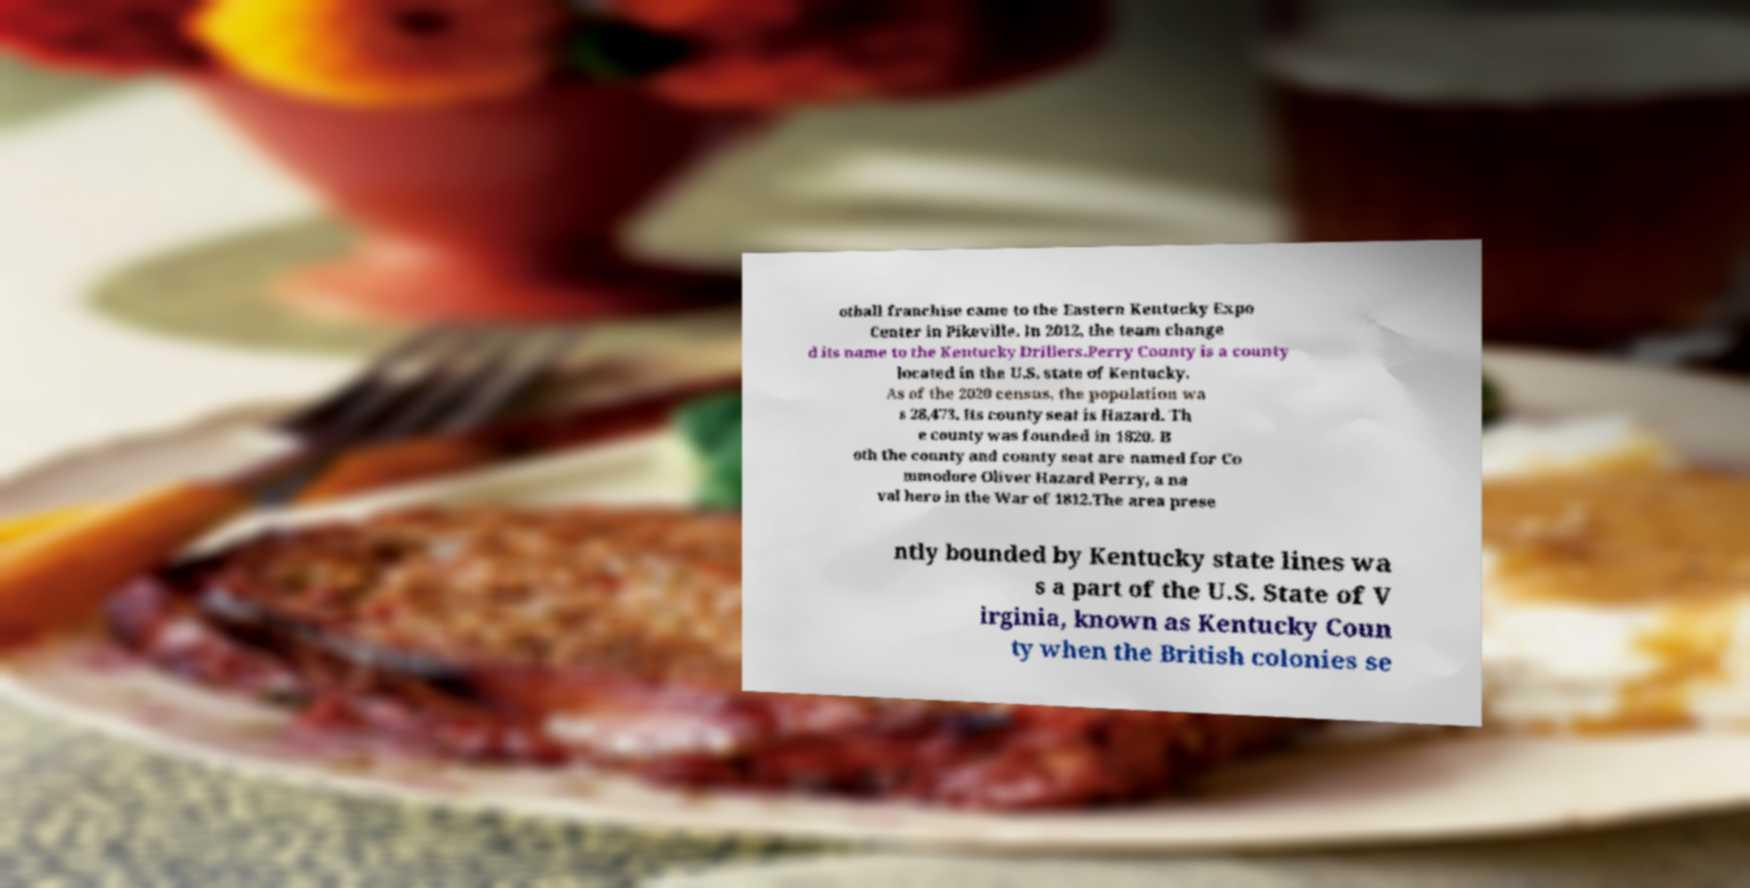Could you extract and type out the text from this image? otball franchise came to the Eastern Kentucky Expo Center in Pikeville. In 2012, the team change d its name to the Kentucky Drillers.Perry County is a county located in the U.S. state of Kentucky. As of the 2020 census, the population wa s 28,473. Its county seat is Hazard. Th e county was founded in 1820. B oth the county and county seat are named for Co mmodore Oliver Hazard Perry, a na val hero in the War of 1812.The area prese ntly bounded by Kentucky state lines wa s a part of the U.S. State of V irginia, known as Kentucky Coun ty when the British colonies se 